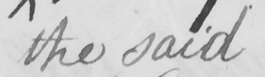Transcribe the text shown in this historical manuscript line. the said 